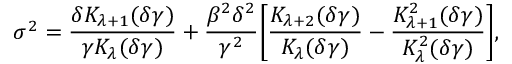Convert formula to latex. <formula><loc_0><loc_0><loc_500><loc_500>\sigma ^ { 2 } = \frac { \delta K _ { \lambda + 1 } ( \delta \gamma ) } { \gamma K _ { \lambda } ( \delta \gamma ) } + \frac { \beta ^ { 2 } \delta ^ { 2 } } { \gamma ^ { 2 } } \left [ \frac { K _ { \lambda + 2 } ( \delta \gamma ) } { K _ { \lambda } ( \delta \gamma ) } - \frac { K _ { \lambda + 1 } ^ { 2 } ( \delta \gamma ) } { K _ { \lambda } ^ { 2 } ( \delta \gamma ) } \right ] ,</formula> 